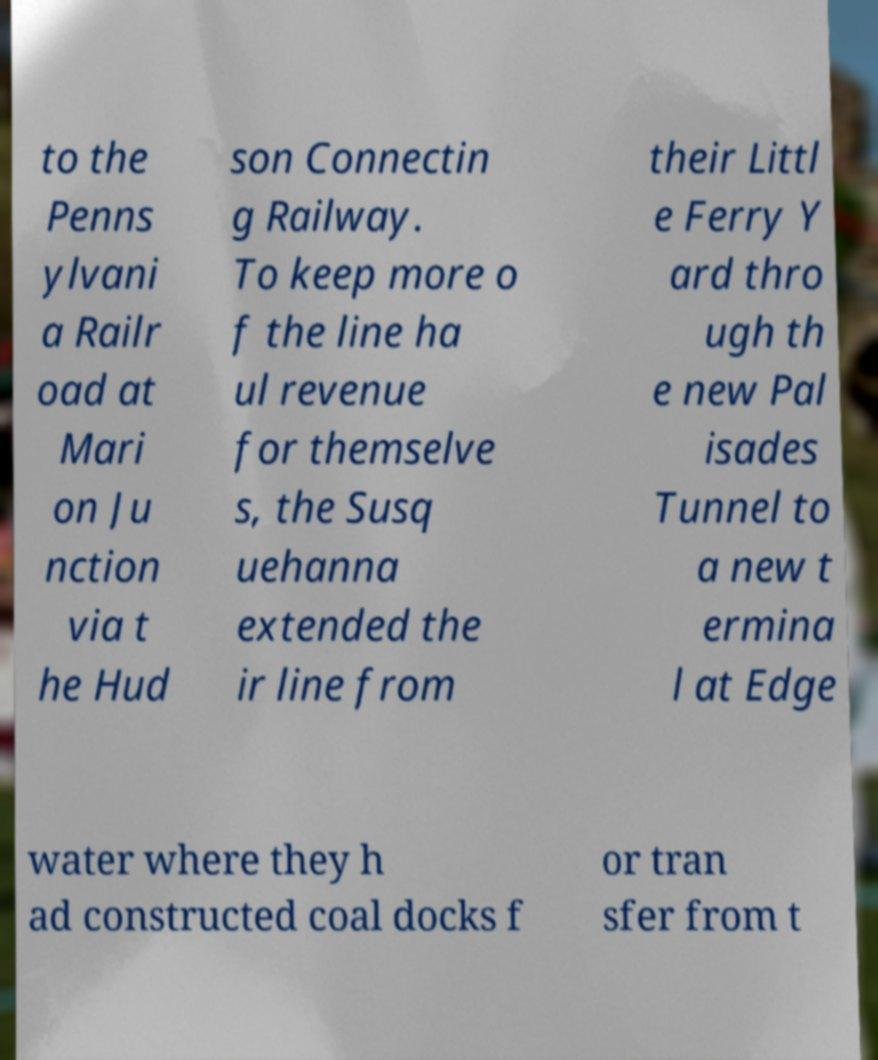I need the written content from this picture converted into text. Can you do that? to the Penns ylvani a Railr oad at Mari on Ju nction via t he Hud son Connectin g Railway. To keep more o f the line ha ul revenue for themselve s, the Susq uehanna extended the ir line from their Littl e Ferry Y ard thro ugh th e new Pal isades Tunnel to a new t ermina l at Edge water where they h ad constructed coal docks f or tran sfer from t 